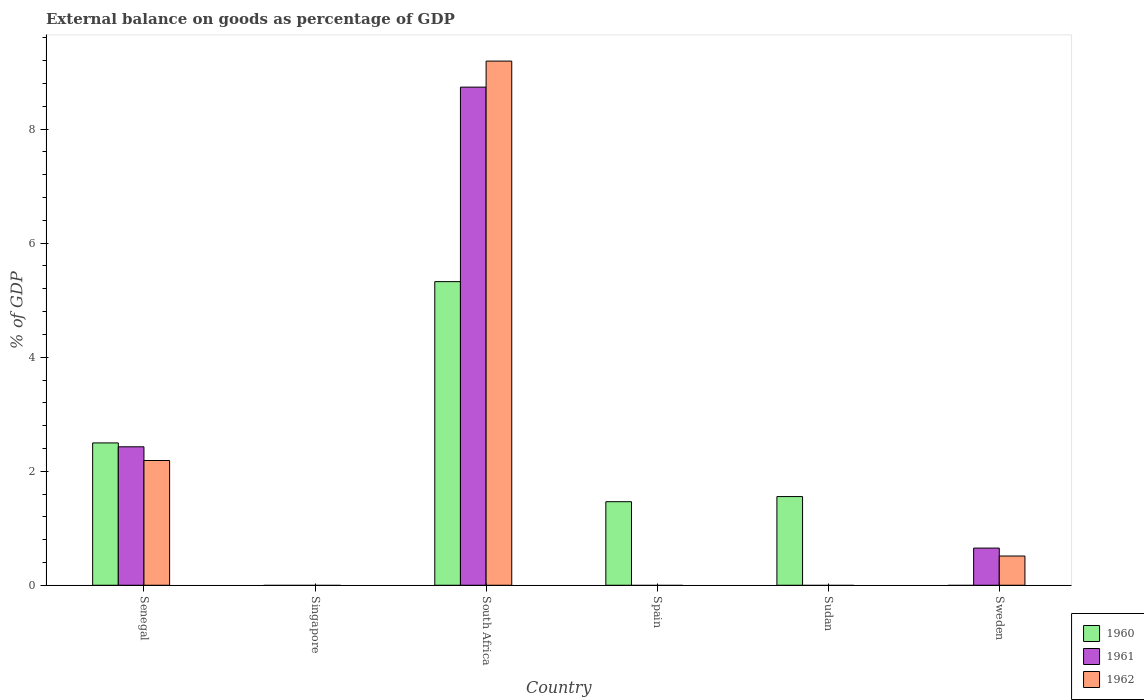How many different coloured bars are there?
Make the answer very short. 3. How many bars are there on the 5th tick from the left?
Your response must be concise. 1. How many bars are there on the 4th tick from the right?
Your response must be concise. 3. What is the label of the 6th group of bars from the left?
Your answer should be compact. Sweden. In how many cases, is the number of bars for a given country not equal to the number of legend labels?
Keep it short and to the point. 4. Across all countries, what is the maximum external balance on goods as percentage of GDP in 1962?
Your answer should be very brief. 9.19. In which country was the external balance on goods as percentage of GDP in 1961 maximum?
Keep it short and to the point. South Africa. What is the total external balance on goods as percentage of GDP in 1960 in the graph?
Offer a very short reply. 10.84. What is the difference between the external balance on goods as percentage of GDP in 1960 in Senegal and that in Spain?
Offer a very short reply. 1.03. What is the average external balance on goods as percentage of GDP in 1961 per country?
Provide a succinct answer. 1.97. What is the difference between the external balance on goods as percentage of GDP of/in 1962 and external balance on goods as percentage of GDP of/in 1961 in Senegal?
Ensure brevity in your answer.  -0.24. In how many countries, is the external balance on goods as percentage of GDP in 1962 greater than 8.8 %?
Ensure brevity in your answer.  1. What is the difference between the highest and the second highest external balance on goods as percentage of GDP in 1960?
Offer a very short reply. -0.94. What is the difference between the highest and the lowest external balance on goods as percentage of GDP in 1962?
Offer a terse response. 9.19. In how many countries, is the external balance on goods as percentage of GDP in 1961 greater than the average external balance on goods as percentage of GDP in 1961 taken over all countries?
Ensure brevity in your answer.  2. What is the difference between two consecutive major ticks on the Y-axis?
Offer a very short reply. 2. Does the graph contain any zero values?
Provide a short and direct response. Yes. Where does the legend appear in the graph?
Provide a short and direct response. Bottom right. How many legend labels are there?
Your answer should be very brief. 3. What is the title of the graph?
Keep it short and to the point. External balance on goods as percentage of GDP. Does "2006" appear as one of the legend labels in the graph?
Your response must be concise. No. What is the label or title of the X-axis?
Ensure brevity in your answer.  Country. What is the label or title of the Y-axis?
Give a very brief answer. % of GDP. What is the % of GDP of 1960 in Senegal?
Provide a short and direct response. 2.5. What is the % of GDP of 1961 in Senegal?
Give a very brief answer. 2.43. What is the % of GDP of 1962 in Senegal?
Keep it short and to the point. 2.19. What is the % of GDP of 1960 in Singapore?
Your answer should be very brief. 0. What is the % of GDP in 1961 in Singapore?
Offer a terse response. 0. What is the % of GDP in 1962 in Singapore?
Ensure brevity in your answer.  0. What is the % of GDP of 1960 in South Africa?
Provide a short and direct response. 5.33. What is the % of GDP in 1961 in South Africa?
Ensure brevity in your answer.  8.74. What is the % of GDP of 1962 in South Africa?
Provide a succinct answer. 9.19. What is the % of GDP of 1960 in Spain?
Give a very brief answer. 1.47. What is the % of GDP in 1961 in Spain?
Make the answer very short. 0. What is the % of GDP in 1960 in Sudan?
Your response must be concise. 1.56. What is the % of GDP of 1962 in Sudan?
Provide a succinct answer. 0. What is the % of GDP in 1960 in Sweden?
Your answer should be compact. 0. What is the % of GDP of 1961 in Sweden?
Offer a terse response. 0.65. What is the % of GDP in 1962 in Sweden?
Provide a succinct answer. 0.51. Across all countries, what is the maximum % of GDP in 1960?
Your answer should be compact. 5.33. Across all countries, what is the maximum % of GDP of 1961?
Your answer should be very brief. 8.74. Across all countries, what is the maximum % of GDP of 1962?
Ensure brevity in your answer.  9.19. What is the total % of GDP in 1960 in the graph?
Make the answer very short. 10.84. What is the total % of GDP of 1961 in the graph?
Your response must be concise. 11.82. What is the total % of GDP in 1962 in the graph?
Ensure brevity in your answer.  11.89. What is the difference between the % of GDP in 1960 in Senegal and that in South Africa?
Offer a very short reply. -2.83. What is the difference between the % of GDP of 1961 in Senegal and that in South Africa?
Offer a terse response. -6.31. What is the difference between the % of GDP of 1962 in Senegal and that in South Africa?
Offer a terse response. -7.01. What is the difference between the % of GDP in 1960 in Senegal and that in Spain?
Your response must be concise. 1.03. What is the difference between the % of GDP in 1960 in Senegal and that in Sudan?
Keep it short and to the point. 0.94. What is the difference between the % of GDP of 1961 in Senegal and that in Sweden?
Give a very brief answer. 1.78. What is the difference between the % of GDP of 1962 in Senegal and that in Sweden?
Provide a succinct answer. 1.68. What is the difference between the % of GDP of 1960 in South Africa and that in Spain?
Provide a short and direct response. 3.86. What is the difference between the % of GDP in 1960 in South Africa and that in Sudan?
Keep it short and to the point. 3.77. What is the difference between the % of GDP of 1961 in South Africa and that in Sweden?
Provide a succinct answer. 8.09. What is the difference between the % of GDP in 1962 in South Africa and that in Sweden?
Your answer should be compact. 8.68. What is the difference between the % of GDP of 1960 in Spain and that in Sudan?
Ensure brevity in your answer.  -0.09. What is the difference between the % of GDP in 1960 in Senegal and the % of GDP in 1961 in South Africa?
Your answer should be compact. -6.24. What is the difference between the % of GDP of 1960 in Senegal and the % of GDP of 1962 in South Africa?
Ensure brevity in your answer.  -6.7. What is the difference between the % of GDP of 1961 in Senegal and the % of GDP of 1962 in South Africa?
Give a very brief answer. -6.77. What is the difference between the % of GDP in 1960 in Senegal and the % of GDP in 1961 in Sweden?
Ensure brevity in your answer.  1.84. What is the difference between the % of GDP in 1960 in Senegal and the % of GDP in 1962 in Sweden?
Provide a short and direct response. 1.98. What is the difference between the % of GDP of 1961 in Senegal and the % of GDP of 1962 in Sweden?
Your answer should be very brief. 1.92. What is the difference between the % of GDP in 1960 in South Africa and the % of GDP in 1961 in Sweden?
Your answer should be compact. 4.67. What is the difference between the % of GDP in 1960 in South Africa and the % of GDP in 1962 in Sweden?
Provide a succinct answer. 4.81. What is the difference between the % of GDP of 1961 in South Africa and the % of GDP of 1962 in Sweden?
Your response must be concise. 8.22. What is the difference between the % of GDP of 1960 in Spain and the % of GDP of 1961 in Sweden?
Give a very brief answer. 0.81. What is the difference between the % of GDP in 1960 in Spain and the % of GDP in 1962 in Sweden?
Give a very brief answer. 0.95. What is the difference between the % of GDP of 1960 in Sudan and the % of GDP of 1961 in Sweden?
Provide a succinct answer. 0.9. What is the difference between the % of GDP of 1960 in Sudan and the % of GDP of 1962 in Sweden?
Give a very brief answer. 1.04. What is the average % of GDP of 1960 per country?
Provide a short and direct response. 1.81. What is the average % of GDP of 1961 per country?
Keep it short and to the point. 1.97. What is the average % of GDP in 1962 per country?
Make the answer very short. 1.98. What is the difference between the % of GDP of 1960 and % of GDP of 1961 in Senegal?
Offer a terse response. 0.07. What is the difference between the % of GDP in 1960 and % of GDP in 1962 in Senegal?
Ensure brevity in your answer.  0.31. What is the difference between the % of GDP in 1961 and % of GDP in 1962 in Senegal?
Offer a very short reply. 0.24. What is the difference between the % of GDP of 1960 and % of GDP of 1961 in South Africa?
Your response must be concise. -3.41. What is the difference between the % of GDP in 1960 and % of GDP in 1962 in South Africa?
Provide a short and direct response. -3.87. What is the difference between the % of GDP of 1961 and % of GDP of 1962 in South Africa?
Make the answer very short. -0.46. What is the difference between the % of GDP of 1961 and % of GDP of 1962 in Sweden?
Ensure brevity in your answer.  0.14. What is the ratio of the % of GDP of 1960 in Senegal to that in South Africa?
Make the answer very short. 0.47. What is the ratio of the % of GDP in 1961 in Senegal to that in South Africa?
Make the answer very short. 0.28. What is the ratio of the % of GDP in 1962 in Senegal to that in South Africa?
Keep it short and to the point. 0.24. What is the ratio of the % of GDP of 1960 in Senegal to that in Spain?
Make the answer very short. 1.7. What is the ratio of the % of GDP of 1960 in Senegal to that in Sudan?
Offer a terse response. 1.61. What is the ratio of the % of GDP of 1961 in Senegal to that in Sweden?
Keep it short and to the point. 3.73. What is the ratio of the % of GDP of 1962 in Senegal to that in Sweden?
Your answer should be very brief. 4.27. What is the ratio of the % of GDP of 1960 in South Africa to that in Spain?
Provide a short and direct response. 3.63. What is the ratio of the % of GDP of 1960 in South Africa to that in Sudan?
Your answer should be very brief. 3.42. What is the ratio of the % of GDP of 1961 in South Africa to that in Sweden?
Make the answer very short. 13.41. What is the ratio of the % of GDP of 1962 in South Africa to that in Sweden?
Provide a succinct answer. 17.94. What is the ratio of the % of GDP in 1960 in Spain to that in Sudan?
Give a very brief answer. 0.94. What is the difference between the highest and the second highest % of GDP of 1960?
Your response must be concise. 2.83. What is the difference between the highest and the second highest % of GDP in 1961?
Your answer should be very brief. 6.31. What is the difference between the highest and the second highest % of GDP of 1962?
Make the answer very short. 7.01. What is the difference between the highest and the lowest % of GDP of 1960?
Offer a very short reply. 5.33. What is the difference between the highest and the lowest % of GDP in 1961?
Your answer should be compact. 8.74. What is the difference between the highest and the lowest % of GDP in 1962?
Your answer should be compact. 9.19. 